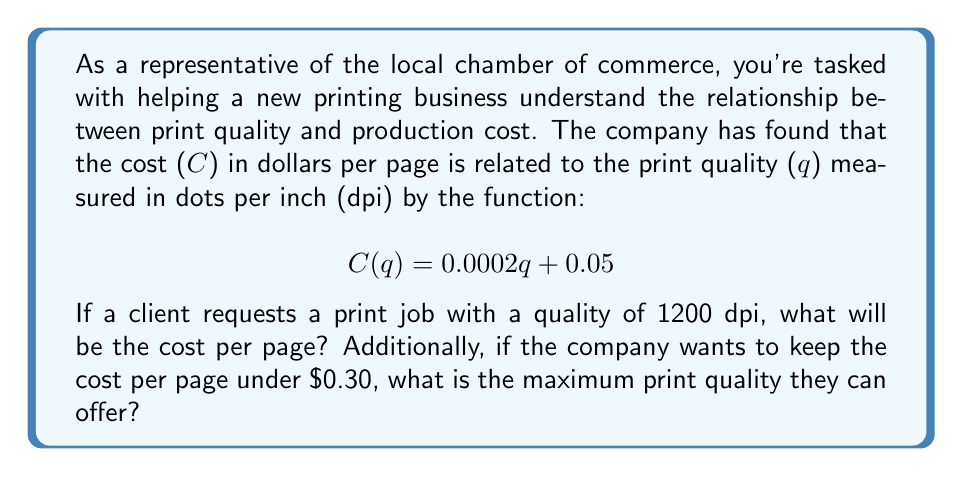Provide a solution to this math problem. To solve this problem, we'll use the given function and perform two separate calculations:

1. Cost per page for 1200 dpi quality:
   We need to evaluate C(q) for q = 1200.
   
   $$C(1200) = 0.0002(1200) + 0.05$$
   $$= 0.24 + 0.05 = 0.29$$

   Therefore, the cost per page for a 1200 dpi print job would be $0.29.

2. Maximum print quality for a cost under $0.30 per page:
   We need to solve the inequality:
   
   $$0.0002q + 0.05 < 0.30$$
   
   Subtracting 0.05 from both sides:
   $$0.0002q < 0.25$$
   
   Dividing both sides by 0.0002:
   $$q < 1250$$

   Since q represents dpi, which must be a whole number, the maximum quality while keeping the cost under $0.30 is 1249 dpi.
Answer: 1. The cost per page for a 1200 dpi print job is $0.29.
2. The maximum print quality while keeping the cost under $0.30 per page is 1249 dpi. 